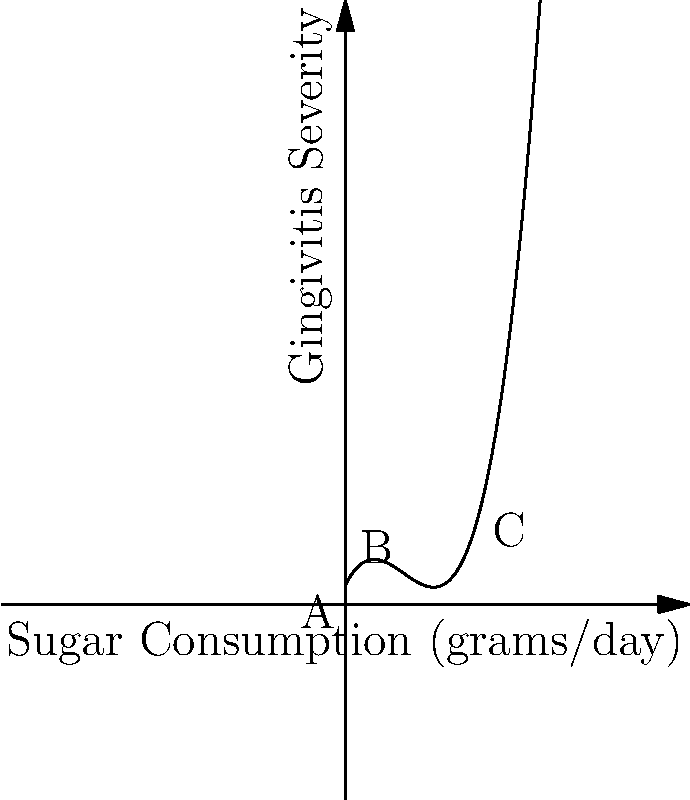The graph above illustrates the relationship between daily sugar consumption and gingivitis severity. Point A represents no sugar consumption, while points B and C show different levels of consumption. At which point does the graph indicate the lowest severity of gingivitis? To determine the point with the lowest severity of gingivitis, we need to analyze the y-values (representing gingivitis severity) at each labeled point:

1. Point A (0, f(0)):
   - This represents no sugar consumption
   - Y-value is relatively high

2. Point B (3, f(3)):
   - This represents moderate sugar consumption
   - Y-value appears to be the lowest among the three points

3. Point C (7, f(7)):
   - This represents high sugar consumption
   - Y-value is the highest among the three points

By visually comparing the y-values (heights) of these points on the graph, we can see that Point B has the lowest y-value, indicating the lowest severity of gingivitis.

This cubic function demonstrates that while no sugar consumption (Point A) is better than high consumption (Point C), there's an optimal point (B) where a moderate amount of sugar consumption correlates with the lowest gingivitis severity. This could be due to various factors, such as the stimulation of saliva production with moderate sugar intake, which helps in maintaining oral health.
Answer: Point B 